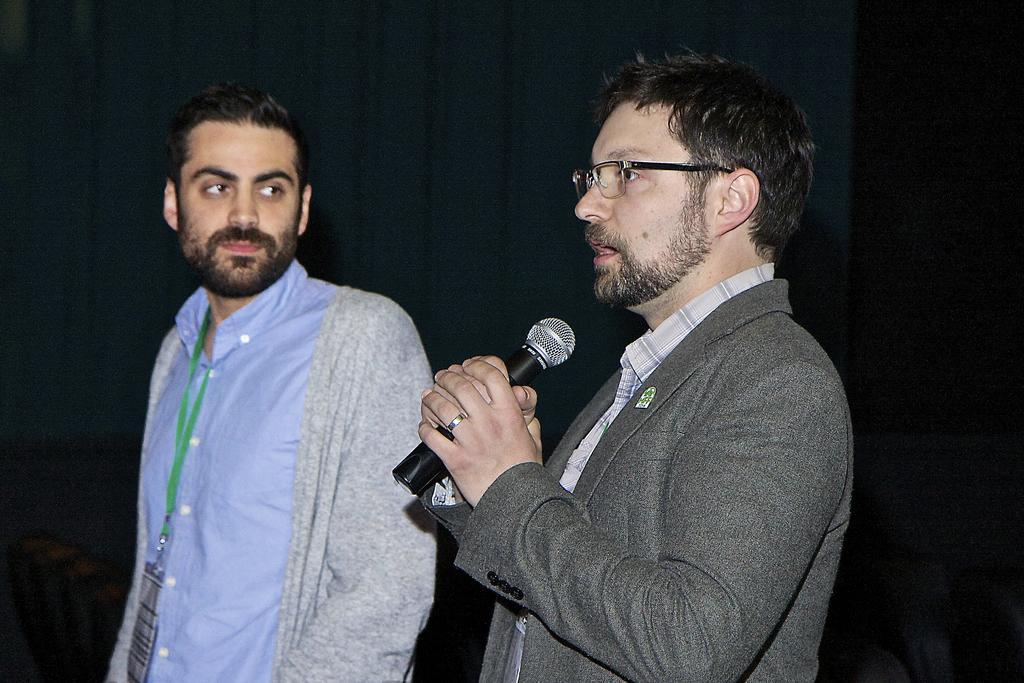Could you give a brief overview of what you see in this image? In this image I can see two men are standing and one is holding a mic. I can also see he is wearing a specs. 